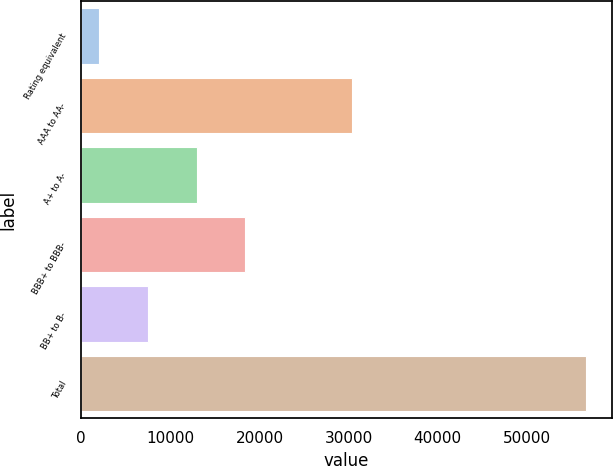Convert chart. <chart><loc_0><loc_0><loc_500><loc_500><bar_chart><fcel>Rating equivalent<fcel>AAA to AA-<fcel>A+ to A-<fcel>BBB+ to BBB-<fcel>BB+ to B-<fcel>Total<nl><fcel>2004<fcel>30384<fcel>12939.4<fcel>18407.1<fcel>7471.7<fcel>56681<nl></chart> 